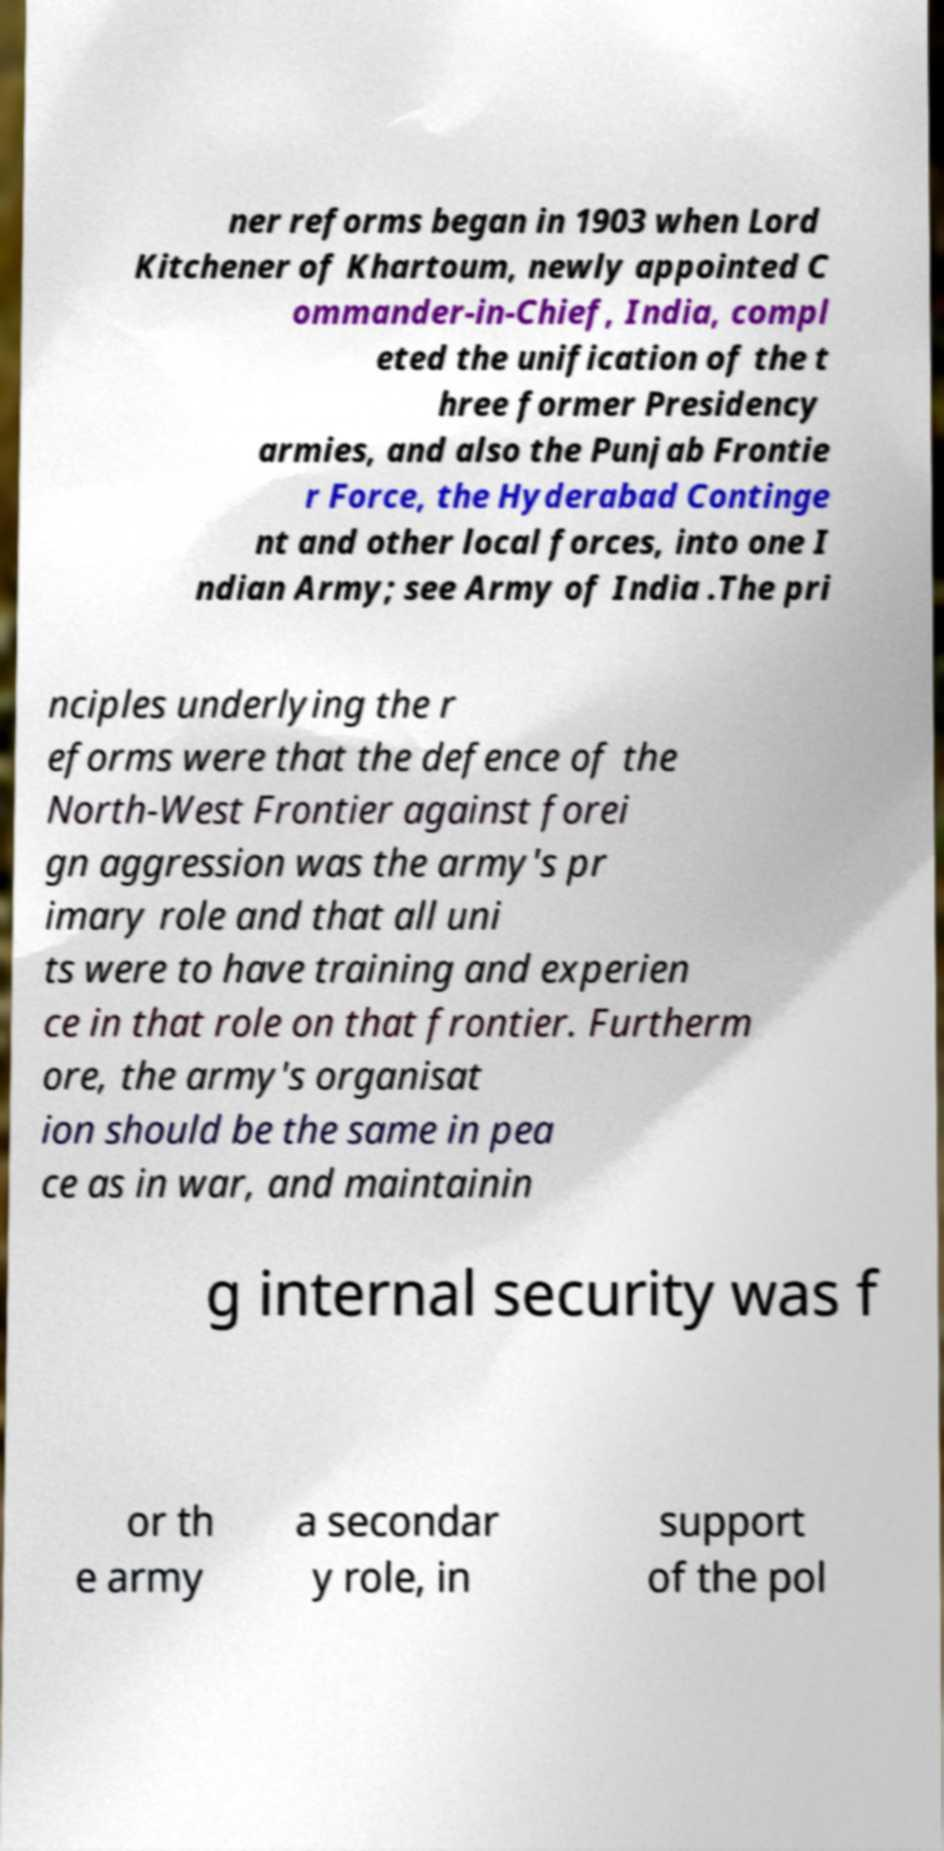There's text embedded in this image that I need extracted. Can you transcribe it verbatim? ner reforms began in 1903 when Lord Kitchener of Khartoum, newly appointed C ommander-in-Chief, India, compl eted the unification of the t hree former Presidency armies, and also the Punjab Frontie r Force, the Hyderabad Continge nt and other local forces, into one I ndian Army; see Army of India .The pri nciples underlying the r eforms were that the defence of the North-West Frontier against forei gn aggression was the army's pr imary role and that all uni ts were to have training and experien ce in that role on that frontier. Furtherm ore, the army's organisat ion should be the same in pea ce as in war, and maintainin g internal security was f or th e army a secondar y role, in support of the pol 